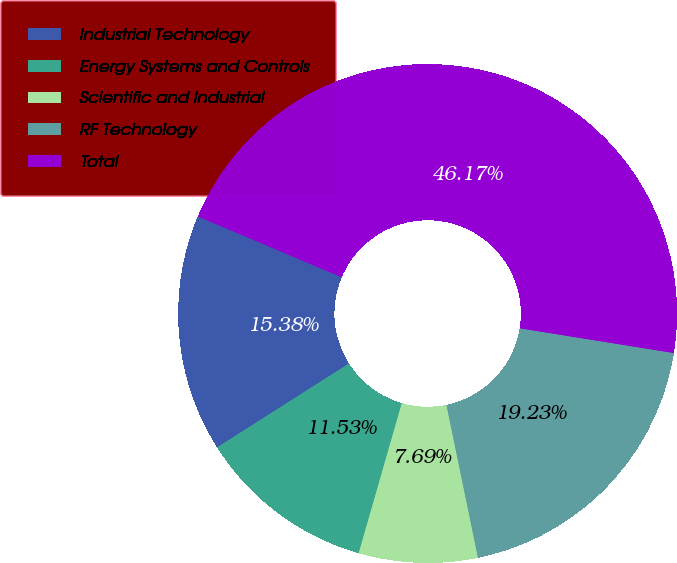Convert chart. <chart><loc_0><loc_0><loc_500><loc_500><pie_chart><fcel>Industrial Technology<fcel>Energy Systems and Controls<fcel>Scientific and Industrial<fcel>RF Technology<fcel>Total<nl><fcel>15.38%<fcel>11.53%<fcel>7.69%<fcel>19.23%<fcel>46.17%<nl></chart> 